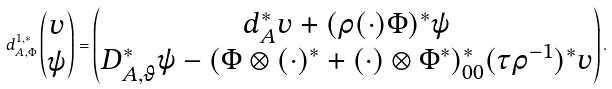<formula> <loc_0><loc_0><loc_500><loc_500>d _ { A , \Phi } ^ { 1 , * } \left ( \begin{matrix} v \\ \psi \end{matrix} \right ) = \left ( \begin{matrix} d _ { A } ^ { * } v + ( \rho ( \cdot ) \Phi ) ^ { * } \psi \\ D _ { A , \vartheta } ^ { * } \psi - ( \Phi \otimes ( \cdot ) ^ { * } + ( \cdot ) \otimes { \Phi } ^ { * } ) _ { 0 0 } ^ { * } ( \tau \rho ^ { - 1 } ) ^ { * } v \end{matrix} \right ) .</formula> 